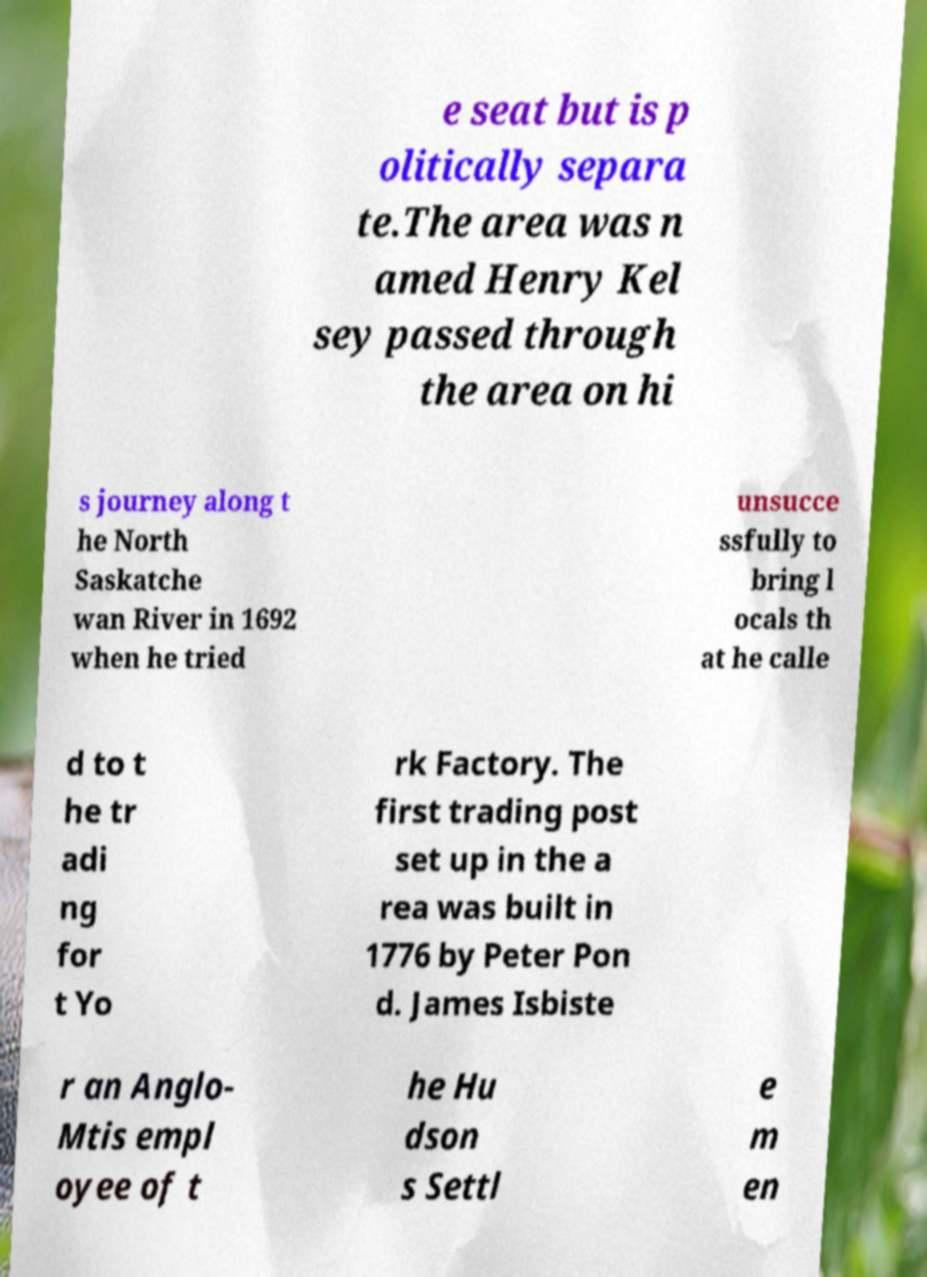There's text embedded in this image that I need extracted. Can you transcribe it verbatim? e seat but is p olitically separa te.The area was n amed Henry Kel sey passed through the area on hi s journey along t he North Saskatche wan River in 1692 when he tried unsucce ssfully to bring l ocals th at he calle d to t he tr adi ng for t Yo rk Factory. The first trading post set up in the a rea was built in 1776 by Peter Pon d. James Isbiste r an Anglo- Mtis empl oyee of t he Hu dson s Settl e m en 